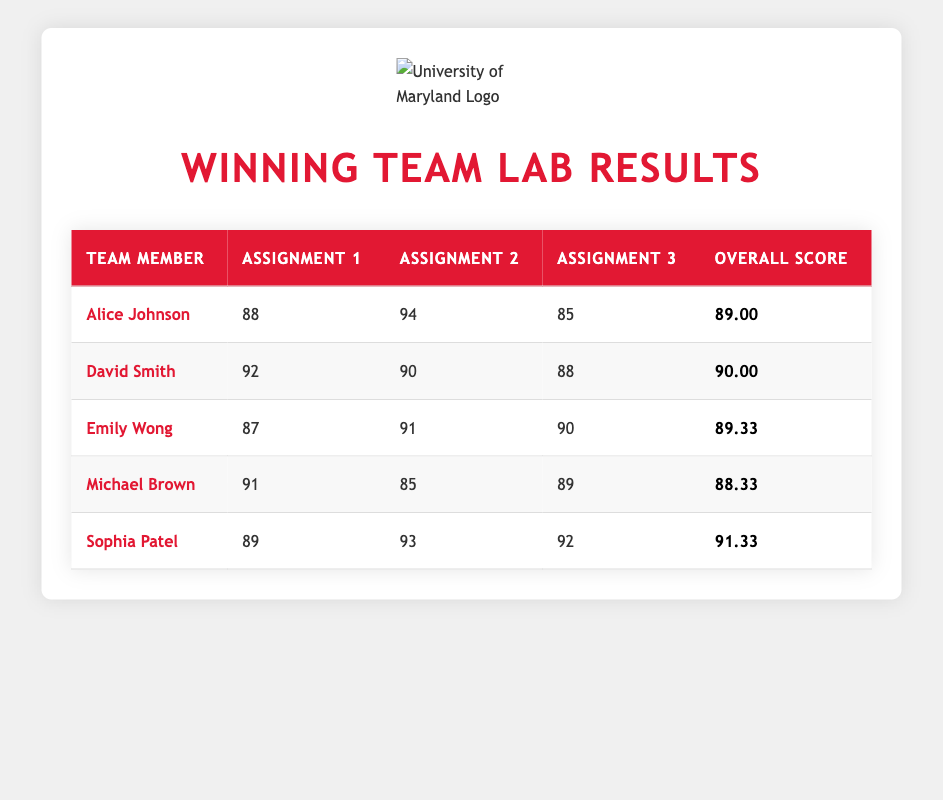What was Alice Johnson's overall score? The overall score for Alice Johnson is found in the last column of the row corresponding to her name. It shows "89.00."
Answer: 89.00 What was the highest score achieved by any team member on Assignment 2? To find the highest score on Assignment 2, look through the second column of all team members. The highest value is "94," which belongs to Alice Johnson.
Answer: 94 Which team member had the lowest score on Assignment 3? The scores for Assignment 3 are observed in the third column. Comparing all the scores (85, 88, 90, 89, 92), the lowest score is "85," which belongs to Alice Johnson.
Answer: Alice Johnson What is the average overall score of the team members? To calculate the average, sum all the overall scores: (89.00 + 90.00 + 89.33 + 88.33 + 91.33) = 448.00. Then, divide by the number of team members (5): 448.00 / 5 = 89.60.
Answer: 89.60 Did any team member score below 90 on all assignments? By examining the scores across the assignments, David Smith is the only member with the highest assignment scores below 90 (he scored 88 on Assignment 3). Therefore, the answer is "Yes."
Answer: Yes Which team member had the greatest difference between their highest and lowest assignment scores? The highest and lowest scores of each member need to be calculated. For instance, Alice had scores of 94 and 85 (difference of 9), and David had scores of 92 and 88 (difference of 4). Analyzing all team members, the greatest difference is for Alice Johnson (9).
Answer: Alice Johnson How many team members scored above 90 in at least one assignment? Checking each assignment’s scores reveals that Alice Johnson, David Smith, Sophia Patel scored above 90 in at least one assignment, totaling three team members.
Answer: 3 Was Emily Wong the team member with the highest overall score? The overall scores of all team members need to be compared. Emily Wong's score is 89.33, while Sophia Patel has a higher score of 91.33. Thus, Emily Wong did not have the highest overall score.
Answer: No What is the sum of scores for all assignments for Michael Brown? The scores for Michael Brown in each assignment are 91 (Assignment 1), 85 (Assignment 2), and 89 (Assignment 3). Adding these together gives 91 + 85 + 89 = 265.
Answer: 265 